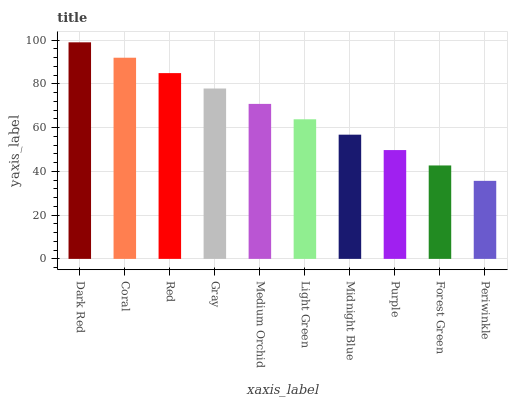Is Coral the minimum?
Answer yes or no. No. Is Coral the maximum?
Answer yes or no. No. Is Dark Red greater than Coral?
Answer yes or no. Yes. Is Coral less than Dark Red?
Answer yes or no. Yes. Is Coral greater than Dark Red?
Answer yes or no. No. Is Dark Red less than Coral?
Answer yes or no. No. Is Medium Orchid the high median?
Answer yes or no. Yes. Is Light Green the low median?
Answer yes or no. Yes. Is Coral the high median?
Answer yes or no. No. Is Purple the low median?
Answer yes or no. No. 